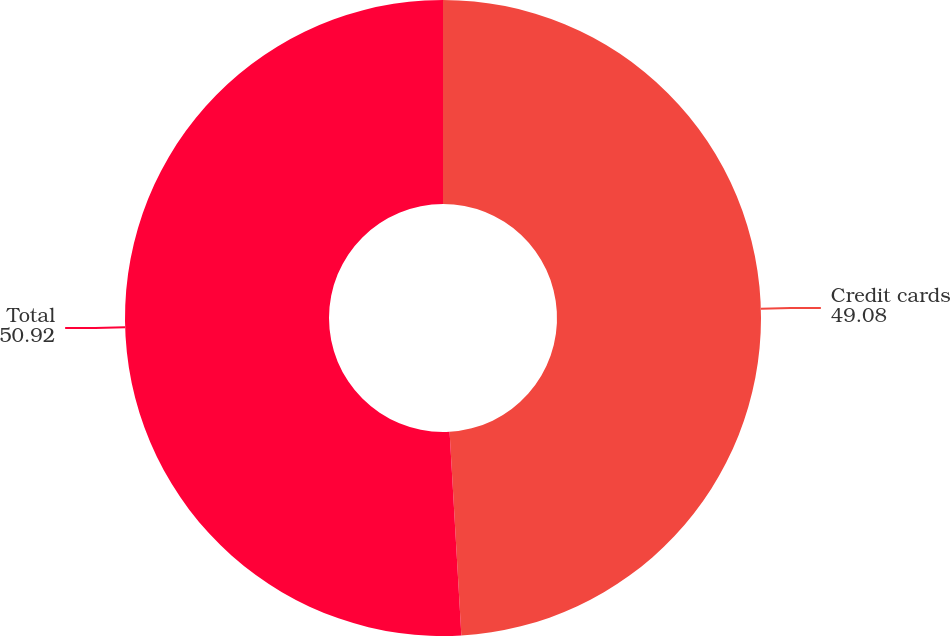<chart> <loc_0><loc_0><loc_500><loc_500><pie_chart><fcel>Credit cards<fcel>Total<nl><fcel>49.08%<fcel>50.92%<nl></chart> 